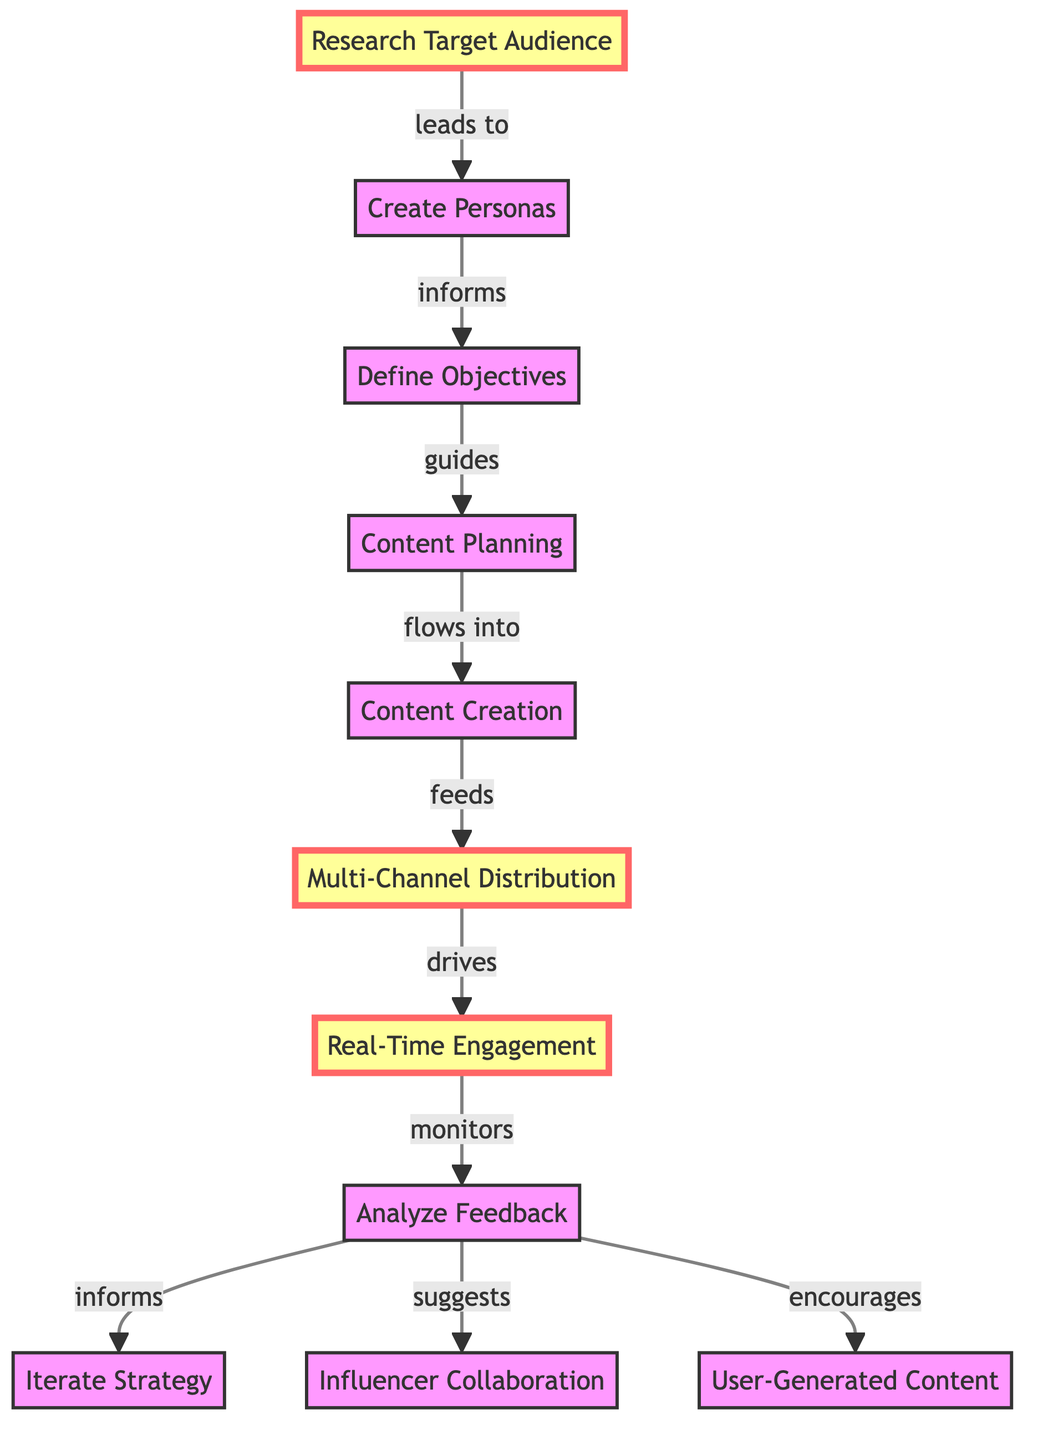What is the first step in the social media content strategy? The first step is "Research Target Audience," which is the starting point of the directed graph.
Answer: Research Target Audience How many nodes are present in the diagram? By counting all the unique nodes listed in the data, the total number of nodes is eleven.
Answer: 11 What does "Multi-Channel Distribution" lead to? Looking at the edges, "Multi-Channel Distribution" drives "Real-Time Engagement."
Answer: Real-Time Engagement Which step follows "Analyze Feedback"? According to the flow, "Analyze Feedback" informs "Iterate Strategy."
Answer: Iterate Strategy What action is encouraged by "Analyze Feedback"? The analysis suggests a positive action resulting in "User-Generated Content."
Answer: User-Generated Content What do the edges between "Content Planning" and "Content Creation" represent? The edge indicates that "Content Planning" flows into "Content Creation," illustrating a directional relationship between these stages.
Answer: flows into What is suggested by the "Analyze Feedback"? The feedback analysis leads to two outputs: it suggests "Influencer Collaboration" and encourages "User-Generated Content."
Answer: Influencer Collaboration, User-Generated Content How does "Real-Time Engagement" relate to "Analyze Feedback"? "Real-Time Engagement" monitors "Analyze Feedback," showing an oversight role that feeds back into the engagement process.
Answer: monitors Which nodes are highlighted in the diagram? The highlighted nodes include "Research Target Audience," "Multi-Channel Distribution," and "Real-Time Engagement."
Answer: Research Target Audience, Multi-Channel Distribution, Real-Time Engagement 